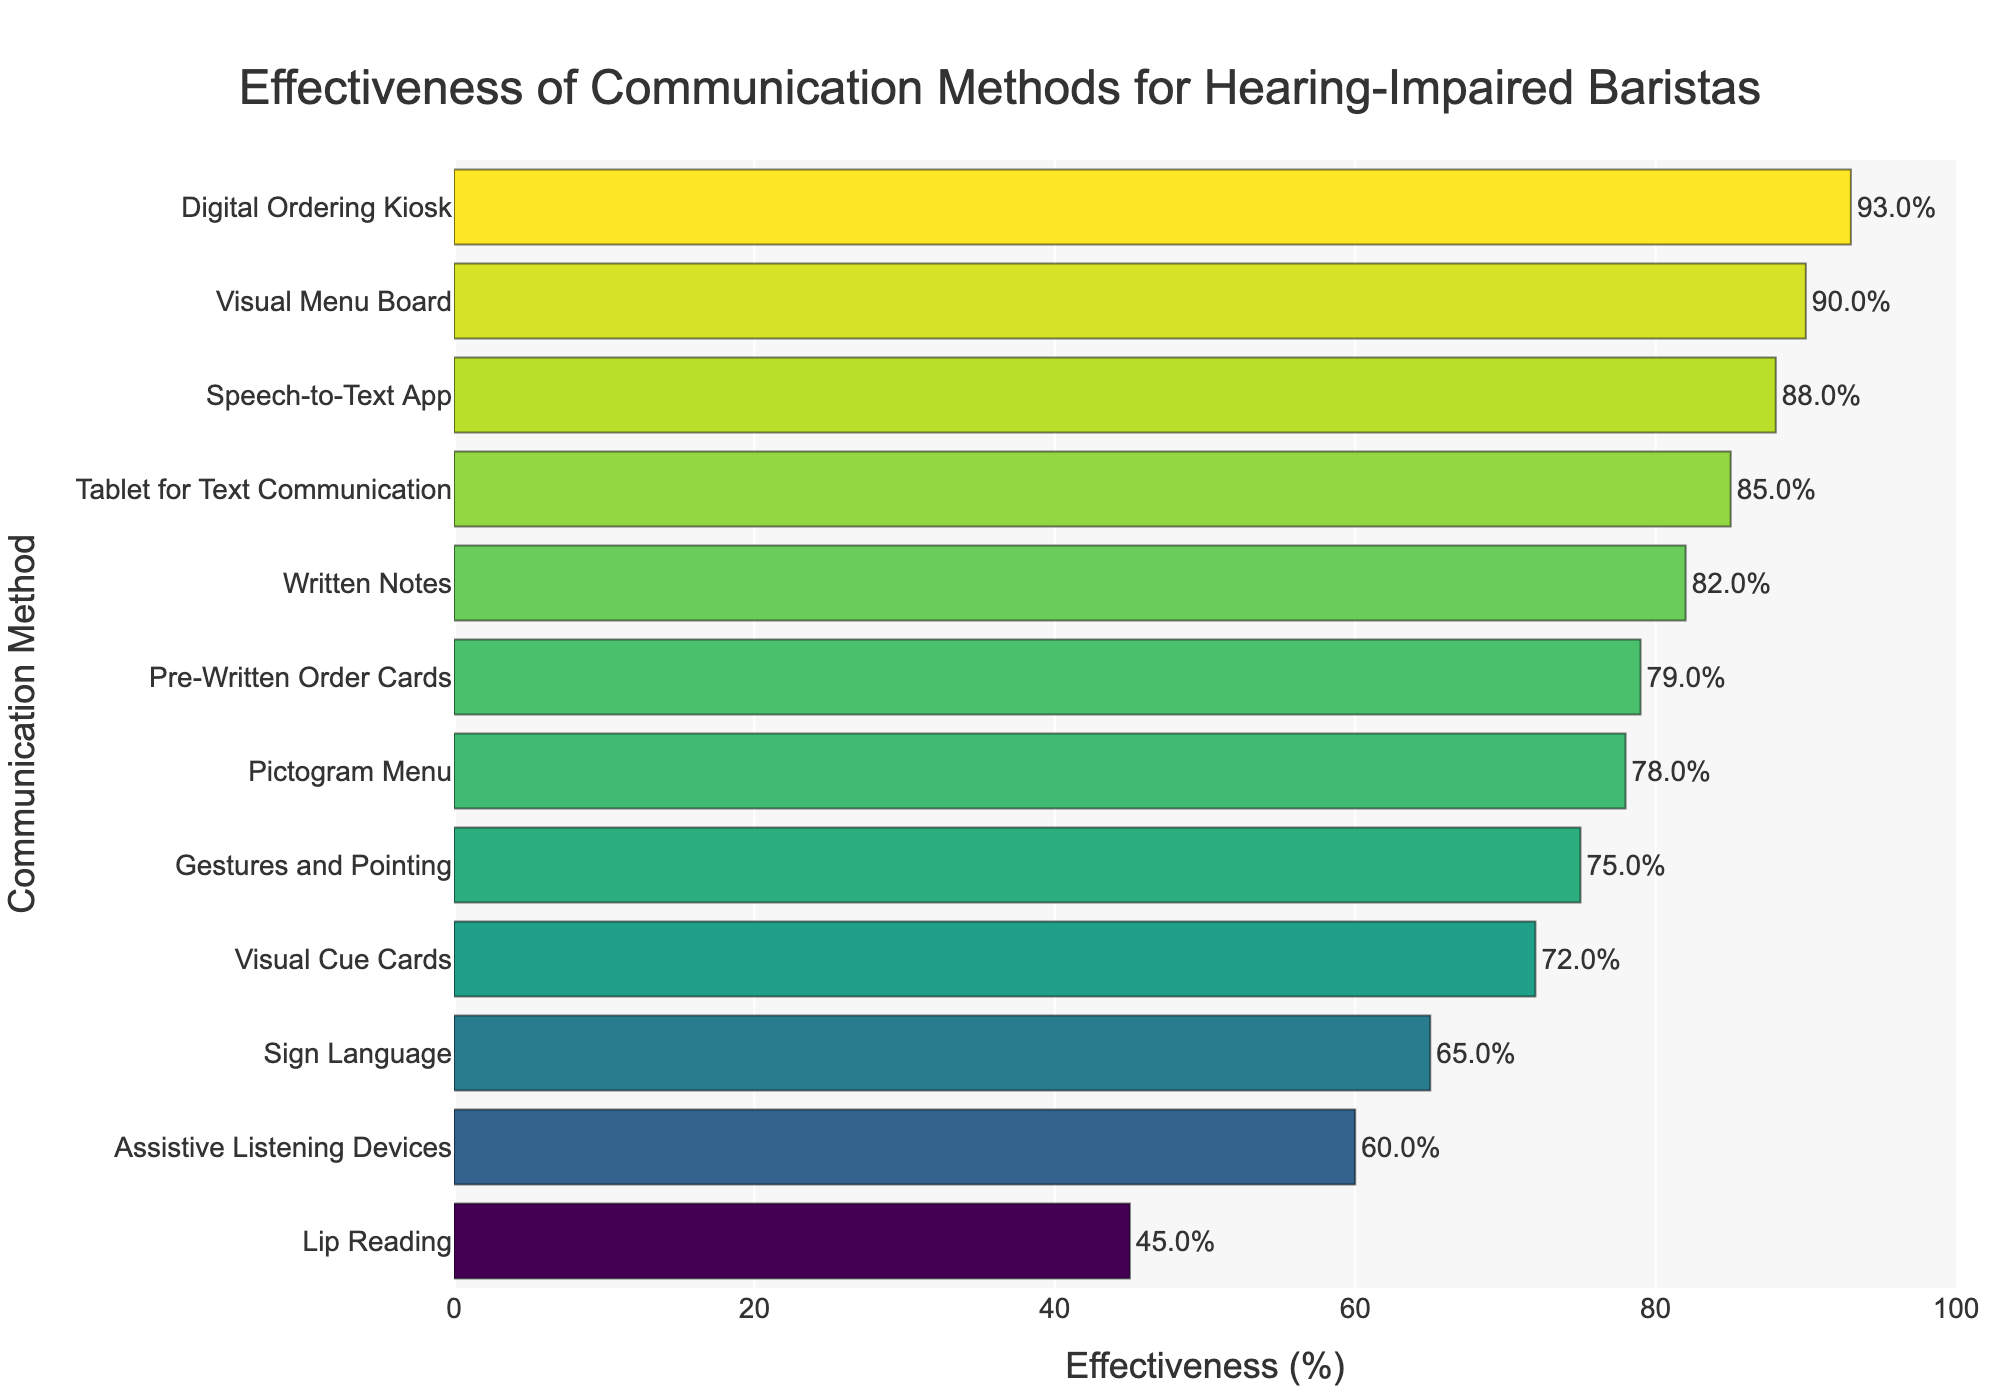Which communication method has the highest effectiveness? The visual menu board has the highest bar in the chart at 93%.
Answer: Digital Ordering Kiosk Which communication method has the lowest effectiveness? Lip Reading has the smallest bar at 45%.
Answer: Lip Reading What is the difference in effectiveness between Written Notes and Gestures and Pointing? Written Notes have an effectiveness of 82% and Gestures and Pointing have 75%. Subtract 75 from 82 to get the difference.
Answer: 7% Which methods have effectiveness greater than 80% but less than 90%? Methods with bars in the range 80-90% are Written Notes (82%), Speech-to-Text App (88%), and Tablet for Text Communication (85%).
Answer: Written Notes, Speech-to-Text App, Tablet for Text Communication What is the average effectiveness of Sign Language and Visual Cue Cards? Sign Language has 65% and Visual Cue Cards have 72%. Sum them up (65 + 72) and divide by 2.
Answer: 68.5% Which methods have an effectiveness of more than 85%? Methods with bars higher than 85% are Visual Menu Board (90%), Speech-to-Text App (88%), Tablet for Text Communication (85%), and Digital Ordering Kiosk (93%).
Answer: Visual Menu Board, Speech-to-Text App, Tablet for Text Communication, Digital Ordering Kiosk How much higher is the effectiveness of the Speech-to-Text App compared to Lip Reading? The effectiveness of Speech-to-Text App is 88% and Lip Reading is 45%. Subtract 45 from 88.
Answer: 43% Among Pre-Written Order Cards, Visual Cue Cards, and Pictogram Menu, which one has the highest effectiveness? Pre-Written Order Cards have 79%, Visual Cue Cards have 72%, and Pictogram Menu has 78%. The highest value is 79%.
Answer: Pre-Written Order Cards What is the sum of the effectiveness percentages of Sign Language and Assistive Listening Devices? Sign Language has 65% and Assistive Listening Devices have 60%. Add them together (65 + 60).
Answer: 125% Is the effectiveness of Gestures and Pointing higher or lower than that of Tablet for Text Communication? Gestures and Pointing have 75% and Tablet for Text Communication have 85%. 75% is lower than 85%.
Answer: Lower 